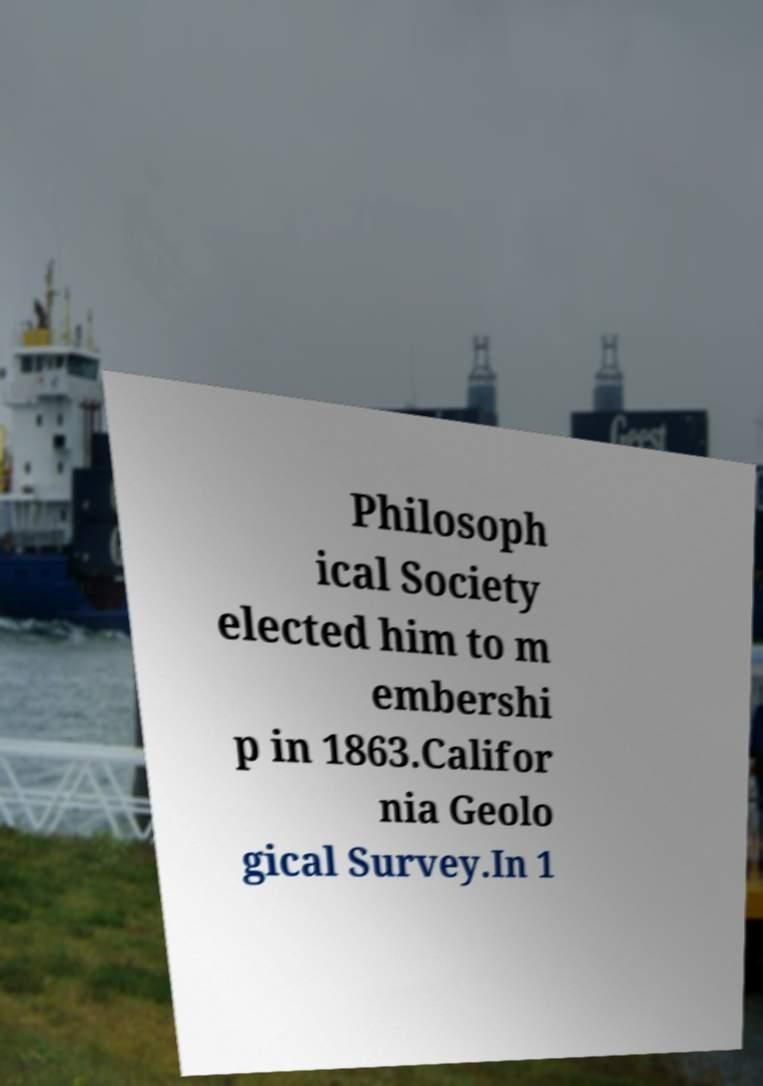Can you read and provide the text displayed in the image?This photo seems to have some interesting text. Can you extract and type it out for me? Philosoph ical Society elected him to m embershi p in 1863.Califor nia Geolo gical Survey.In 1 